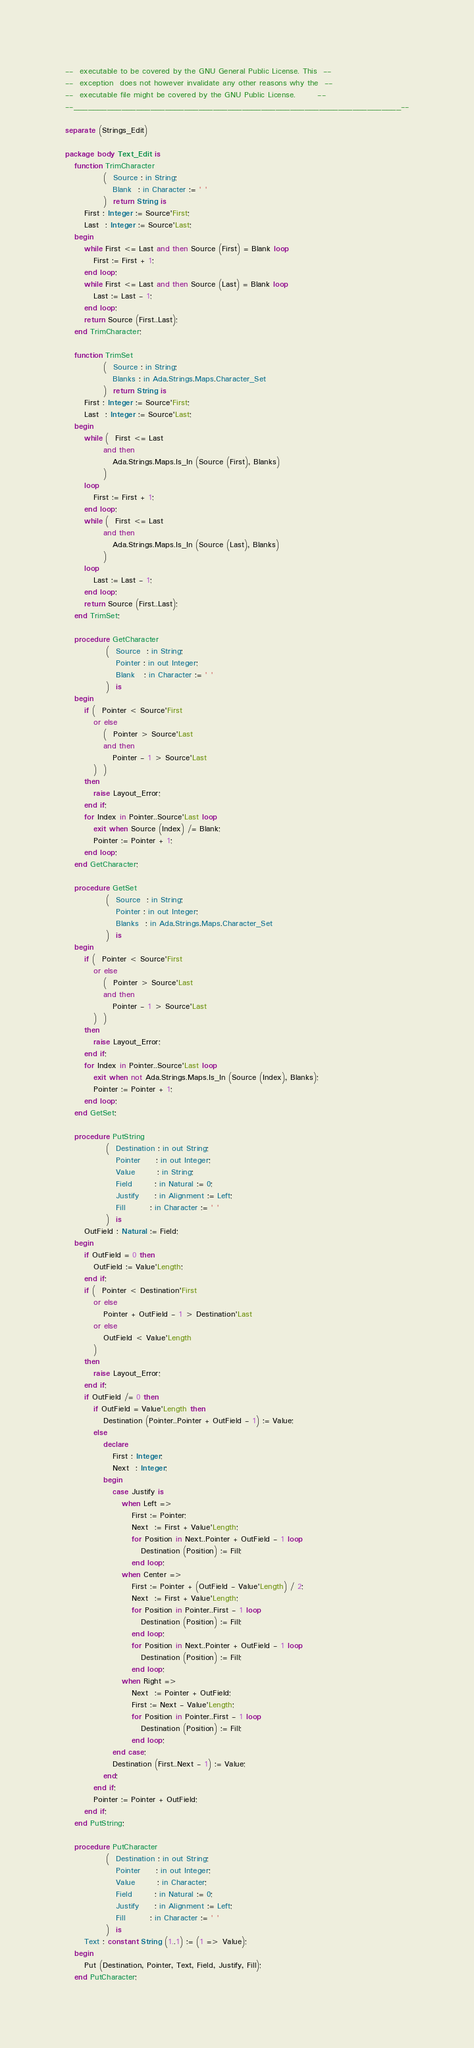<code> <loc_0><loc_0><loc_500><loc_500><_Ada_>--  executable to be covered by the GNU General Public License. This  --
--  exception  does not however invalidate any other reasons why the  --
--  executable file might be covered by the GNU Public License.       --
--____________________________________________________________________--

separate (Strings_Edit)

package body Text_Edit is
   function TrimCharacter
            (  Source : in String;
               Blank  : in Character := ' '
            )  return String is
      First : Integer := Source'First;
      Last  : Integer := Source'Last;
   begin
      while First <= Last and then Source (First) = Blank loop
         First := First + 1;
      end loop;
      while First <= Last and then Source (Last) = Blank loop
         Last := Last - 1;
      end loop;
      return Source (First..Last);
   end TrimCharacter;
   
   function TrimSet
            (  Source : in String;
               Blanks : in Ada.Strings.Maps.Character_Set
            )  return String is
      First : Integer := Source'First;
      Last  : Integer := Source'Last;
   begin
      while (  First <= Last
            and then
               Ada.Strings.Maps.Is_In (Source (First), Blanks)
            )
      loop
         First := First + 1;
      end loop;
      while (  First <= Last
            and then
               Ada.Strings.Maps.Is_In (Source (Last), Blanks)
            )
      loop
         Last := Last - 1;
      end loop;
      return Source (First..Last);
   end TrimSet;

   procedure GetCharacter
             (  Source  : in String;
                Pointer : in out Integer;
                Blank   : in Character := ' '
             )  is
   begin
      if (  Pointer < Source'First
         or else
            (  Pointer > Source'Last
            and then
               Pointer - 1 > Source'Last
         )  )
      then
         raise Layout_Error;
      end if;
      for Index in Pointer..Source'Last loop
         exit when Source (Index) /= Blank;
         Pointer := Pointer + 1;
      end loop;
   end GetCharacter;

   procedure GetSet
             (  Source  : in String;
                Pointer : in out Integer;
                Blanks  : in Ada.Strings.Maps.Character_Set
             )  is
   begin
      if (  Pointer < Source'First
         or else
            (  Pointer > Source'Last
            and then
               Pointer - 1 > Source'Last
         )  )
      then
         raise Layout_Error;
      end if;
      for Index in Pointer..Source'Last loop
         exit when not Ada.Strings.Maps.Is_In (Source (Index), Blanks);
         Pointer := Pointer + 1;
      end loop;
   end GetSet;

   procedure PutString
             (  Destination : in out String;
                Pointer     : in out Integer;
                Value       : in String;
                Field       : in Natural := 0;
                Justify     : in Alignment := Left;
                Fill        : in Character := ' '
             )  is
      OutField : Natural := Field;
   begin
      if OutField = 0 then
         OutField := Value'Length;
      end if;
      if (  Pointer < Destination'First
         or else
            Pointer + OutField - 1 > Destination'Last
         or else
            OutField < Value'Length
         )
      then
         raise Layout_Error;
      end if;
      if OutField /= 0 then
         if OutField = Value'Length then
            Destination (Pointer..Pointer + OutField - 1) := Value;
         else
            declare
               First : Integer;
               Next  : Integer;
            begin
               case Justify is
                  when Left =>
                     First := Pointer;
                     Next  := First + Value'Length;
                     for Position in Next..Pointer + OutField - 1 loop
                        Destination (Position) := Fill;
                     end loop;
                  when Center =>
                     First := Pointer + (OutField - Value'Length) / 2;
                     Next  := First + Value'Length;
                     for Position in Pointer..First - 1 loop
                        Destination (Position) := Fill;
                     end loop;
                     for Position in Next..Pointer + OutField - 1 loop
                        Destination (Position) := Fill;
                     end loop;
                  when Right =>
                     Next  := Pointer + OutField;
                     First := Next - Value'Length;
                     for Position in Pointer..First - 1 loop
                        Destination (Position) := Fill;
                     end loop;
               end case;
               Destination (First..Next - 1) := Value;
            end;
         end if;
         Pointer := Pointer + OutField;
      end if;
   end PutString;
   
   procedure PutCharacter
             (  Destination : in out String;
                Pointer     : in out Integer;
                Value       : in Character;
                Field       : in Natural := 0;
                Justify     : in Alignment := Left;
                Fill        : in Character := ' '
             )  is
      Text : constant String (1..1) := (1 => Value);
   begin
      Put (Destination, Pointer, Text, Field, Justify, Fill);
   end PutCharacter;</code> 